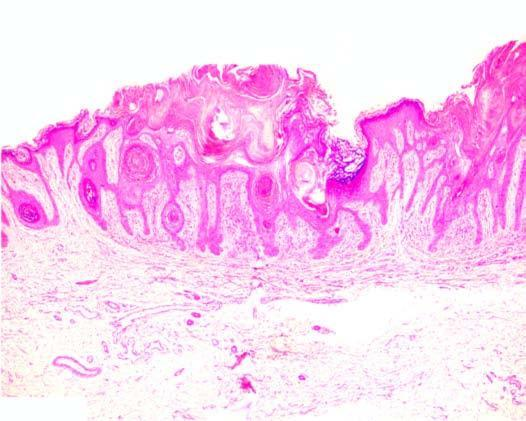do the other features include papillomatosis, hyperkeratosis and acanthosis?
Answer the question using a single word or phrase. Yes 